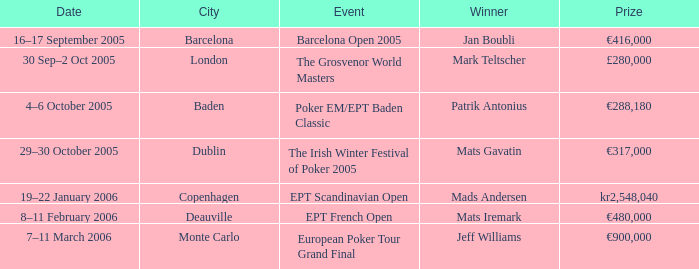When was the event in Dublin? 29–30 October 2005. 